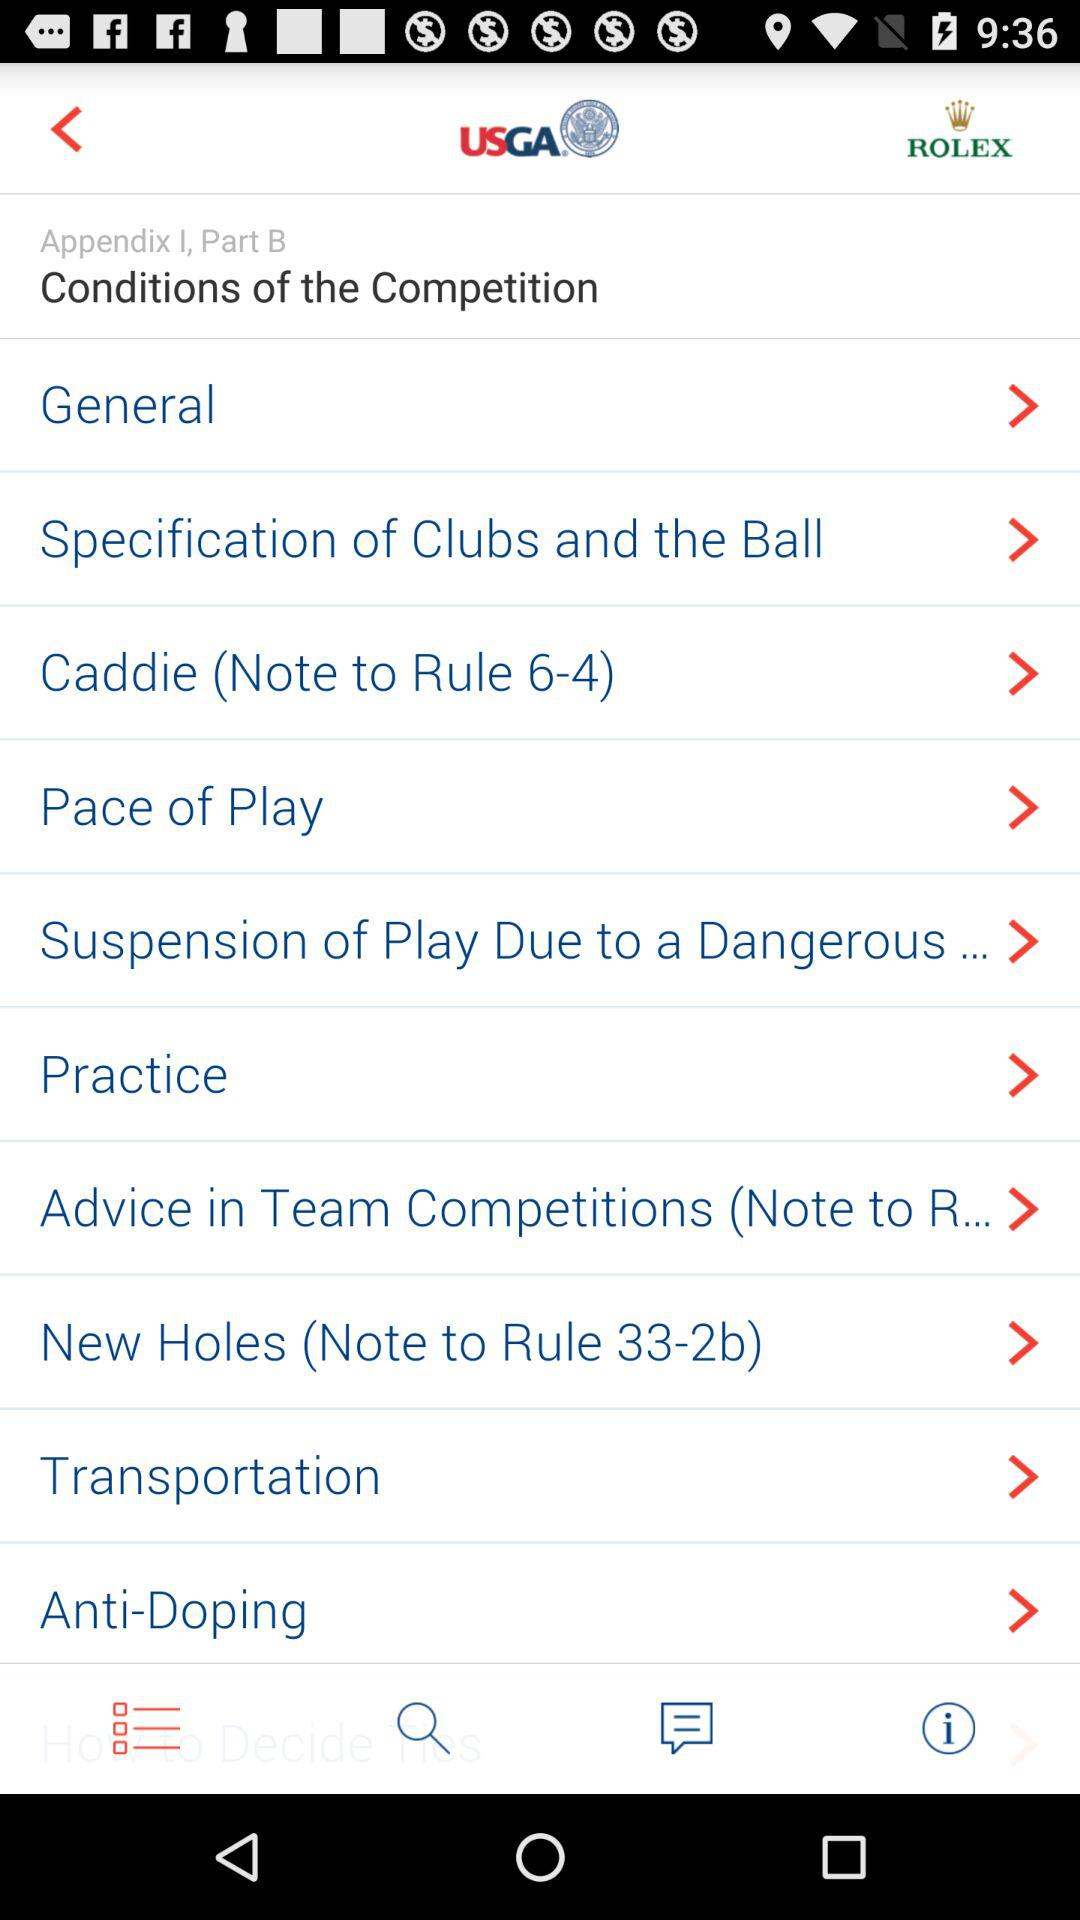What are the "Conditions of the Competition"? The conditions are "General", "Specification of Clubs and the Ball", "Caddie", "Pace of Play", "Suspension of Play Due to a Dangerous...", "Practice", "Advice in Team Competitions (Note to R...", "New Holes (Note to Rule 33-2b)", "Transportation" and "Anti-Doping". 